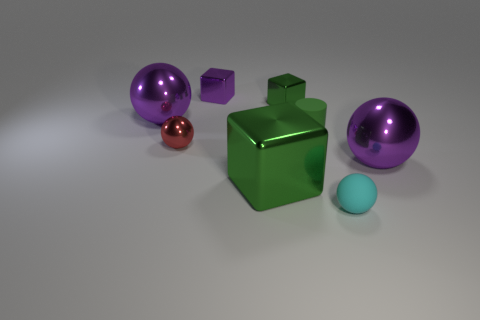Subtract all small matte spheres. How many spheres are left? 3 Add 1 cyan objects. How many objects exist? 9 Subtract all blocks. How many objects are left? 5 Subtract all purple blocks. How many blocks are left? 2 Subtract all big metallic things. Subtract all small purple things. How many objects are left? 4 Add 7 small green rubber things. How many small green rubber things are left? 8 Add 7 green blocks. How many green blocks exist? 9 Subtract 0 green spheres. How many objects are left? 8 Subtract 4 spheres. How many spheres are left? 0 Subtract all yellow cylinders. Subtract all cyan cubes. How many cylinders are left? 1 